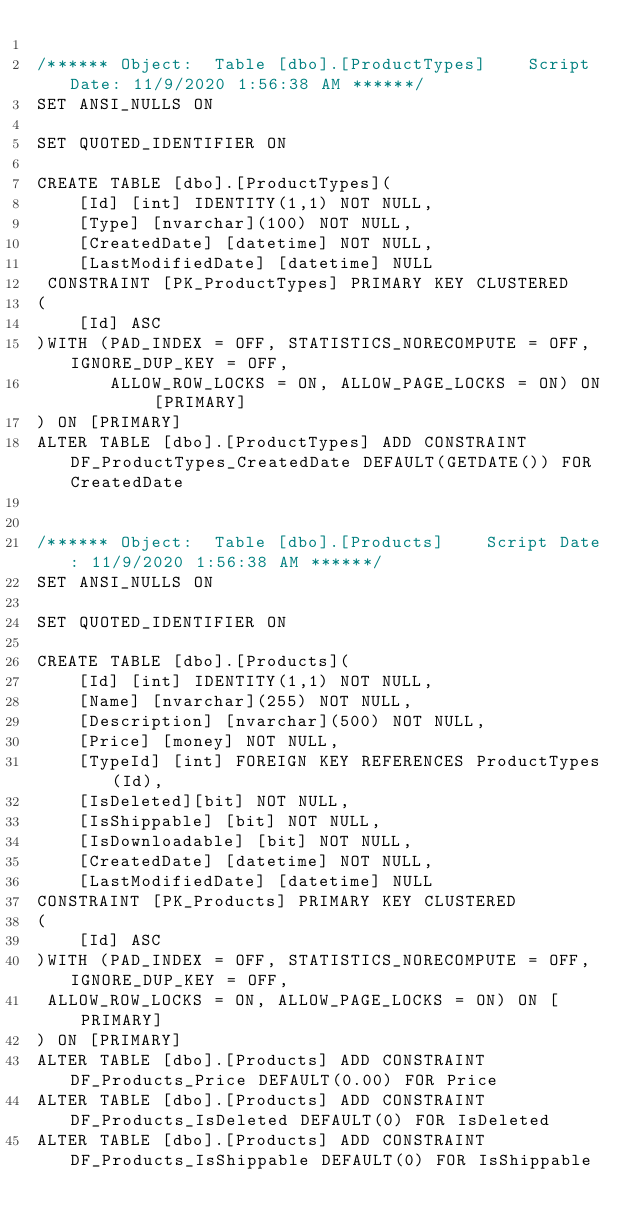Convert code to text. <code><loc_0><loc_0><loc_500><loc_500><_SQL_>
/****** Object:  Table [dbo].[ProductTypes]    Script Date: 11/9/2020 1:56:38 AM ******/
SET ANSI_NULLS ON

SET QUOTED_IDENTIFIER ON

CREATE TABLE [dbo].[ProductTypes](
	[Id] [int] IDENTITY(1,1) NOT NULL,
	[Type] [nvarchar](100) NOT NULL,
	[CreatedDate] [datetime] NOT NULL,
	[LastModifiedDate] [datetime] NULL
 CONSTRAINT [PK_ProductTypes] PRIMARY KEY CLUSTERED 
(
	[Id] ASC
)WITH (PAD_INDEX = OFF, STATISTICS_NORECOMPUTE = OFF, IGNORE_DUP_KEY = OFF, 
       ALLOW_ROW_LOCKS = ON, ALLOW_PAGE_LOCKS = ON) ON [PRIMARY]
) ON [PRIMARY]
ALTER TABLE [dbo].[ProductTypes] ADD CONSTRAINT DF_ProductTypes_CreatedDate DEFAULT(GETDATE()) FOR CreatedDate


/****** Object:  Table [dbo].[Products]    Script Date: 11/9/2020 1:56:38 AM ******/
SET ANSI_NULLS ON

SET QUOTED_IDENTIFIER ON

CREATE TABLE [dbo].[Products](
	[Id] [int] IDENTITY(1,1) NOT NULL,
	[Name] [nvarchar](255) NOT NULL,
	[Description] [nvarchar](500) NOT NULL,
	[Price] [money] NOT NULL,
	[TypeId] [int] FOREIGN KEY REFERENCES ProductTypes(Id),
	[IsDeleted][bit] NOT NULL,
	[IsShippable] [bit] NOT NULL,
	[IsDownloadable] [bit] NOT NULL,
	[CreatedDate] [datetime] NOT NULL,
	[LastModifiedDate] [datetime] NULL
CONSTRAINT [PK_Products] PRIMARY KEY CLUSTERED 
(
	[Id] ASC
)WITH (PAD_INDEX = OFF, STATISTICS_NORECOMPUTE = OFF, IGNORE_DUP_KEY = OFF, 
 ALLOW_ROW_LOCKS = ON, ALLOW_PAGE_LOCKS = ON) ON [PRIMARY]
) ON [PRIMARY]
ALTER TABLE [dbo].[Products] ADD CONSTRAINT DF_Products_Price DEFAULT(0.00) FOR Price
ALTER TABLE [dbo].[Products] ADD CONSTRAINT DF_Products_IsDeleted DEFAULT(0) FOR IsDeleted
ALTER TABLE [dbo].[Products] ADD CONSTRAINT DF_Products_IsShippable DEFAULT(0) FOR IsShippable</code> 